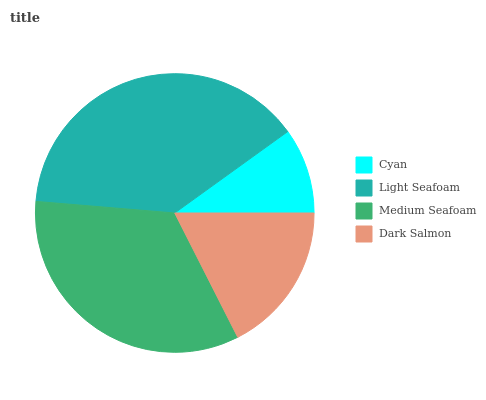Is Cyan the minimum?
Answer yes or no. Yes. Is Light Seafoam the maximum?
Answer yes or no. Yes. Is Medium Seafoam the minimum?
Answer yes or no. No. Is Medium Seafoam the maximum?
Answer yes or no. No. Is Light Seafoam greater than Medium Seafoam?
Answer yes or no. Yes. Is Medium Seafoam less than Light Seafoam?
Answer yes or no. Yes. Is Medium Seafoam greater than Light Seafoam?
Answer yes or no. No. Is Light Seafoam less than Medium Seafoam?
Answer yes or no. No. Is Medium Seafoam the high median?
Answer yes or no. Yes. Is Dark Salmon the low median?
Answer yes or no. Yes. Is Dark Salmon the high median?
Answer yes or no. No. Is Light Seafoam the low median?
Answer yes or no. No. 